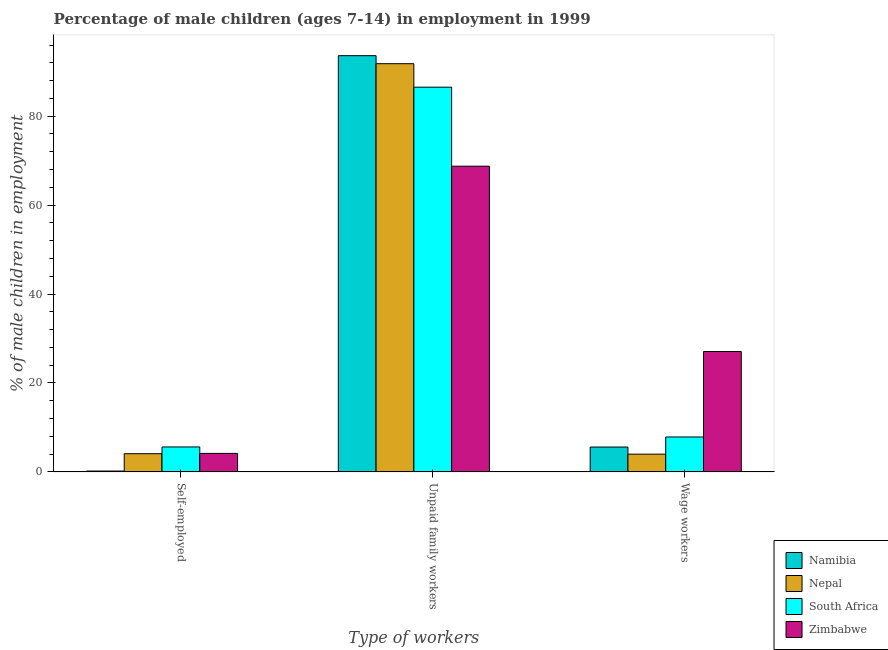How many different coloured bars are there?
Your response must be concise. 4. What is the label of the 1st group of bars from the left?
Make the answer very short. Self-employed. Across all countries, what is the maximum percentage of self employed children?
Offer a terse response. 5.62. Across all countries, what is the minimum percentage of children employed as unpaid family workers?
Your response must be concise. 68.75. In which country was the percentage of self employed children maximum?
Offer a terse response. South Africa. In which country was the percentage of children employed as unpaid family workers minimum?
Your answer should be very brief. Zimbabwe. What is the total percentage of children employed as wage workers in the graph?
Your answer should be very brief. 44.54. What is the difference between the percentage of self employed children in Zimbabwe and that in Namibia?
Provide a short and direct response. 3.97. What is the difference between the percentage of self employed children in Nepal and the percentage of children employed as unpaid family workers in South Africa?
Keep it short and to the point. -82.42. What is the average percentage of children employed as wage workers per country?
Give a very brief answer. 11.13. What is the difference between the percentage of self employed children and percentage of children employed as unpaid family workers in South Africa?
Offer a terse response. -80.9. In how many countries, is the percentage of children employed as unpaid family workers greater than 56 %?
Offer a terse response. 4. What is the ratio of the percentage of children employed as wage workers in Nepal to that in South Africa?
Your answer should be very brief. 0.51. Is the percentage of children employed as wage workers in Nepal less than that in Namibia?
Keep it short and to the point. Yes. Is the difference between the percentage of children employed as unpaid family workers in South Africa and Nepal greater than the difference between the percentage of self employed children in South Africa and Nepal?
Your answer should be compact. No. What is the difference between the highest and the second highest percentage of children employed as unpaid family workers?
Provide a short and direct response. 1.8. What is the difference between the highest and the lowest percentage of children employed as unpaid family workers?
Ensure brevity in your answer.  24.85. In how many countries, is the percentage of self employed children greater than the average percentage of self employed children taken over all countries?
Make the answer very short. 3. What does the 2nd bar from the left in Wage workers represents?
Provide a short and direct response. Nepal. What does the 1st bar from the right in Wage workers represents?
Provide a succinct answer. Zimbabwe. Are all the bars in the graph horizontal?
Ensure brevity in your answer.  No. How many countries are there in the graph?
Offer a very short reply. 4. What is the difference between two consecutive major ticks on the Y-axis?
Keep it short and to the point. 20. Does the graph contain any zero values?
Provide a short and direct response. No. Where does the legend appear in the graph?
Your answer should be compact. Bottom right. How many legend labels are there?
Provide a short and direct response. 4. What is the title of the graph?
Your response must be concise. Percentage of male children (ages 7-14) in employment in 1999. Does "Niger" appear as one of the legend labels in the graph?
Offer a terse response. No. What is the label or title of the X-axis?
Your answer should be compact. Type of workers. What is the label or title of the Y-axis?
Offer a very short reply. % of male children in employment. What is the % of male children in employment of Nepal in Self-employed?
Your answer should be very brief. 4.1. What is the % of male children in employment in South Africa in Self-employed?
Give a very brief answer. 5.62. What is the % of male children in employment in Zimbabwe in Self-employed?
Your answer should be very brief. 4.17. What is the % of male children in employment of Namibia in Unpaid family workers?
Give a very brief answer. 93.6. What is the % of male children in employment in Nepal in Unpaid family workers?
Offer a terse response. 91.8. What is the % of male children in employment in South Africa in Unpaid family workers?
Provide a succinct answer. 86.52. What is the % of male children in employment in Zimbabwe in Unpaid family workers?
Your answer should be compact. 68.75. What is the % of male children in employment of Namibia in Wage workers?
Keep it short and to the point. 5.6. What is the % of male children in employment of South Africa in Wage workers?
Your answer should be compact. 7.86. What is the % of male children in employment of Zimbabwe in Wage workers?
Offer a very short reply. 27.08. Across all Type of workers, what is the maximum % of male children in employment of Namibia?
Keep it short and to the point. 93.6. Across all Type of workers, what is the maximum % of male children in employment in Nepal?
Provide a succinct answer. 91.8. Across all Type of workers, what is the maximum % of male children in employment of South Africa?
Ensure brevity in your answer.  86.52. Across all Type of workers, what is the maximum % of male children in employment of Zimbabwe?
Offer a very short reply. 68.75. Across all Type of workers, what is the minimum % of male children in employment in Namibia?
Offer a very short reply. 0.2. Across all Type of workers, what is the minimum % of male children in employment of Nepal?
Your response must be concise. 4. Across all Type of workers, what is the minimum % of male children in employment in South Africa?
Keep it short and to the point. 5.62. Across all Type of workers, what is the minimum % of male children in employment in Zimbabwe?
Keep it short and to the point. 4.17. What is the total % of male children in employment of Namibia in the graph?
Your answer should be very brief. 99.4. What is the total % of male children in employment of Nepal in the graph?
Your answer should be very brief. 99.9. What is the total % of male children in employment in South Africa in the graph?
Keep it short and to the point. 100. What is the total % of male children in employment in Zimbabwe in the graph?
Ensure brevity in your answer.  100. What is the difference between the % of male children in employment in Namibia in Self-employed and that in Unpaid family workers?
Offer a terse response. -93.4. What is the difference between the % of male children in employment of Nepal in Self-employed and that in Unpaid family workers?
Your answer should be compact. -87.7. What is the difference between the % of male children in employment of South Africa in Self-employed and that in Unpaid family workers?
Give a very brief answer. -80.9. What is the difference between the % of male children in employment in Zimbabwe in Self-employed and that in Unpaid family workers?
Provide a short and direct response. -64.58. What is the difference between the % of male children in employment of South Africa in Self-employed and that in Wage workers?
Provide a short and direct response. -2.24. What is the difference between the % of male children in employment of Zimbabwe in Self-employed and that in Wage workers?
Your response must be concise. -22.91. What is the difference between the % of male children in employment in Nepal in Unpaid family workers and that in Wage workers?
Provide a short and direct response. 87.8. What is the difference between the % of male children in employment of South Africa in Unpaid family workers and that in Wage workers?
Offer a terse response. 78.66. What is the difference between the % of male children in employment in Zimbabwe in Unpaid family workers and that in Wage workers?
Your answer should be very brief. 41.67. What is the difference between the % of male children in employment of Namibia in Self-employed and the % of male children in employment of Nepal in Unpaid family workers?
Ensure brevity in your answer.  -91.6. What is the difference between the % of male children in employment of Namibia in Self-employed and the % of male children in employment of South Africa in Unpaid family workers?
Keep it short and to the point. -86.32. What is the difference between the % of male children in employment in Namibia in Self-employed and the % of male children in employment in Zimbabwe in Unpaid family workers?
Ensure brevity in your answer.  -68.55. What is the difference between the % of male children in employment in Nepal in Self-employed and the % of male children in employment in South Africa in Unpaid family workers?
Offer a very short reply. -82.42. What is the difference between the % of male children in employment in Nepal in Self-employed and the % of male children in employment in Zimbabwe in Unpaid family workers?
Offer a very short reply. -64.65. What is the difference between the % of male children in employment of South Africa in Self-employed and the % of male children in employment of Zimbabwe in Unpaid family workers?
Provide a short and direct response. -63.13. What is the difference between the % of male children in employment in Namibia in Self-employed and the % of male children in employment in Nepal in Wage workers?
Give a very brief answer. -3.8. What is the difference between the % of male children in employment in Namibia in Self-employed and the % of male children in employment in South Africa in Wage workers?
Make the answer very short. -7.66. What is the difference between the % of male children in employment of Namibia in Self-employed and the % of male children in employment of Zimbabwe in Wage workers?
Offer a very short reply. -26.88. What is the difference between the % of male children in employment of Nepal in Self-employed and the % of male children in employment of South Africa in Wage workers?
Offer a very short reply. -3.76. What is the difference between the % of male children in employment in Nepal in Self-employed and the % of male children in employment in Zimbabwe in Wage workers?
Your response must be concise. -22.98. What is the difference between the % of male children in employment of South Africa in Self-employed and the % of male children in employment of Zimbabwe in Wage workers?
Provide a short and direct response. -21.46. What is the difference between the % of male children in employment in Namibia in Unpaid family workers and the % of male children in employment in Nepal in Wage workers?
Your response must be concise. 89.6. What is the difference between the % of male children in employment of Namibia in Unpaid family workers and the % of male children in employment of South Africa in Wage workers?
Your response must be concise. 85.74. What is the difference between the % of male children in employment of Namibia in Unpaid family workers and the % of male children in employment of Zimbabwe in Wage workers?
Ensure brevity in your answer.  66.52. What is the difference between the % of male children in employment of Nepal in Unpaid family workers and the % of male children in employment of South Africa in Wage workers?
Offer a very short reply. 83.94. What is the difference between the % of male children in employment in Nepal in Unpaid family workers and the % of male children in employment in Zimbabwe in Wage workers?
Offer a terse response. 64.72. What is the difference between the % of male children in employment of South Africa in Unpaid family workers and the % of male children in employment of Zimbabwe in Wage workers?
Your answer should be very brief. 59.44. What is the average % of male children in employment of Namibia per Type of workers?
Provide a short and direct response. 33.13. What is the average % of male children in employment of Nepal per Type of workers?
Offer a terse response. 33.3. What is the average % of male children in employment in South Africa per Type of workers?
Provide a short and direct response. 33.33. What is the average % of male children in employment of Zimbabwe per Type of workers?
Offer a very short reply. 33.33. What is the difference between the % of male children in employment in Namibia and % of male children in employment in Nepal in Self-employed?
Offer a very short reply. -3.9. What is the difference between the % of male children in employment in Namibia and % of male children in employment in South Africa in Self-employed?
Give a very brief answer. -5.42. What is the difference between the % of male children in employment of Namibia and % of male children in employment of Zimbabwe in Self-employed?
Offer a terse response. -3.97. What is the difference between the % of male children in employment of Nepal and % of male children in employment of South Africa in Self-employed?
Provide a succinct answer. -1.52. What is the difference between the % of male children in employment of Nepal and % of male children in employment of Zimbabwe in Self-employed?
Ensure brevity in your answer.  -0.07. What is the difference between the % of male children in employment of South Africa and % of male children in employment of Zimbabwe in Self-employed?
Provide a short and direct response. 1.45. What is the difference between the % of male children in employment in Namibia and % of male children in employment in Nepal in Unpaid family workers?
Your answer should be compact. 1.8. What is the difference between the % of male children in employment of Namibia and % of male children in employment of South Africa in Unpaid family workers?
Your answer should be compact. 7.08. What is the difference between the % of male children in employment of Namibia and % of male children in employment of Zimbabwe in Unpaid family workers?
Provide a succinct answer. 24.85. What is the difference between the % of male children in employment of Nepal and % of male children in employment of South Africa in Unpaid family workers?
Keep it short and to the point. 5.28. What is the difference between the % of male children in employment in Nepal and % of male children in employment in Zimbabwe in Unpaid family workers?
Provide a short and direct response. 23.05. What is the difference between the % of male children in employment in South Africa and % of male children in employment in Zimbabwe in Unpaid family workers?
Provide a succinct answer. 17.77. What is the difference between the % of male children in employment in Namibia and % of male children in employment in South Africa in Wage workers?
Your answer should be very brief. -2.26. What is the difference between the % of male children in employment in Namibia and % of male children in employment in Zimbabwe in Wage workers?
Keep it short and to the point. -21.48. What is the difference between the % of male children in employment in Nepal and % of male children in employment in South Africa in Wage workers?
Your answer should be compact. -3.86. What is the difference between the % of male children in employment of Nepal and % of male children in employment of Zimbabwe in Wage workers?
Keep it short and to the point. -23.08. What is the difference between the % of male children in employment of South Africa and % of male children in employment of Zimbabwe in Wage workers?
Keep it short and to the point. -19.22. What is the ratio of the % of male children in employment in Namibia in Self-employed to that in Unpaid family workers?
Your answer should be very brief. 0. What is the ratio of the % of male children in employment of Nepal in Self-employed to that in Unpaid family workers?
Offer a terse response. 0.04. What is the ratio of the % of male children in employment of South Africa in Self-employed to that in Unpaid family workers?
Offer a terse response. 0.07. What is the ratio of the % of male children in employment of Zimbabwe in Self-employed to that in Unpaid family workers?
Offer a very short reply. 0.06. What is the ratio of the % of male children in employment of Namibia in Self-employed to that in Wage workers?
Your answer should be very brief. 0.04. What is the ratio of the % of male children in employment in Nepal in Self-employed to that in Wage workers?
Give a very brief answer. 1.02. What is the ratio of the % of male children in employment of South Africa in Self-employed to that in Wage workers?
Keep it short and to the point. 0.71. What is the ratio of the % of male children in employment in Zimbabwe in Self-employed to that in Wage workers?
Give a very brief answer. 0.15. What is the ratio of the % of male children in employment in Namibia in Unpaid family workers to that in Wage workers?
Ensure brevity in your answer.  16.71. What is the ratio of the % of male children in employment in Nepal in Unpaid family workers to that in Wage workers?
Provide a short and direct response. 22.95. What is the ratio of the % of male children in employment in South Africa in Unpaid family workers to that in Wage workers?
Your answer should be very brief. 11.01. What is the ratio of the % of male children in employment in Zimbabwe in Unpaid family workers to that in Wage workers?
Provide a short and direct response. 2.54. What is the difference between the highest and the second highest % of male children in employment in Namibia?
Make the answer very short. 88. What is the difference between the highest and the second highest % of male children in employment of Nepal?
Your response must be concise. 87.7. What is the difference between the highest and the second highest % of male children in employment of South Africa?
Your answer should be compact. 78.66. What is the difference between the highest and the second highest % of male children in employment of Zimbabwe?
Ensure brevity in your answer.  41.67. What is the difference between the highest and the lowest % of male children in employment of Namibia?
Your response must be concise. 93.4. What is the difference between the highest and the lowest % of male children in employment in Nepal?
Keep it short and to the point. 87.8. What is the difference between the highest and the lowest % of male children in employment in South Africa?
Ensure brevity in your answer.  80.9. What is the difference between the highest and the lowest % of male children in employment of Zimbabwe?
Make the answer very short. 64.58. 